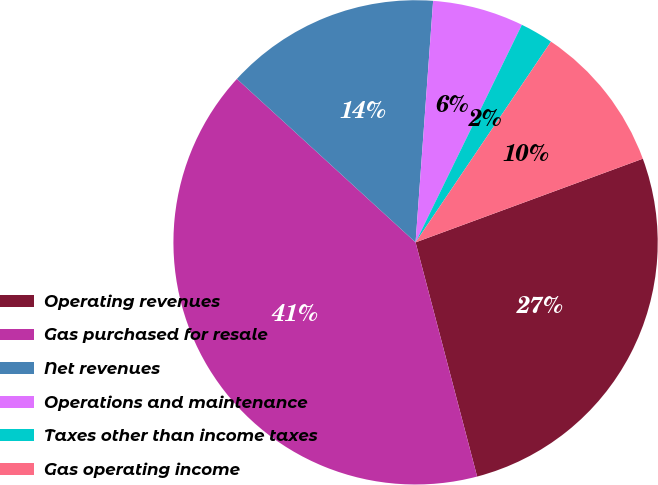Convert chart to OTSL. <chart><loc_0><loc_0><loc_500><loc_500><pie_chart><fcel>Operating revenues<fcel>Gas purchased for resale<fcel>Net revenues<fcel>Operations and maintenance<fcel>Taxes other than income taxes<fcel>Gas operating income<nl><fcel>26.52%<fcel>40.88%<fcel>14.36%<fcel>6.08%<fcel>2.21%<fcel>9.94%<nl></chart> 